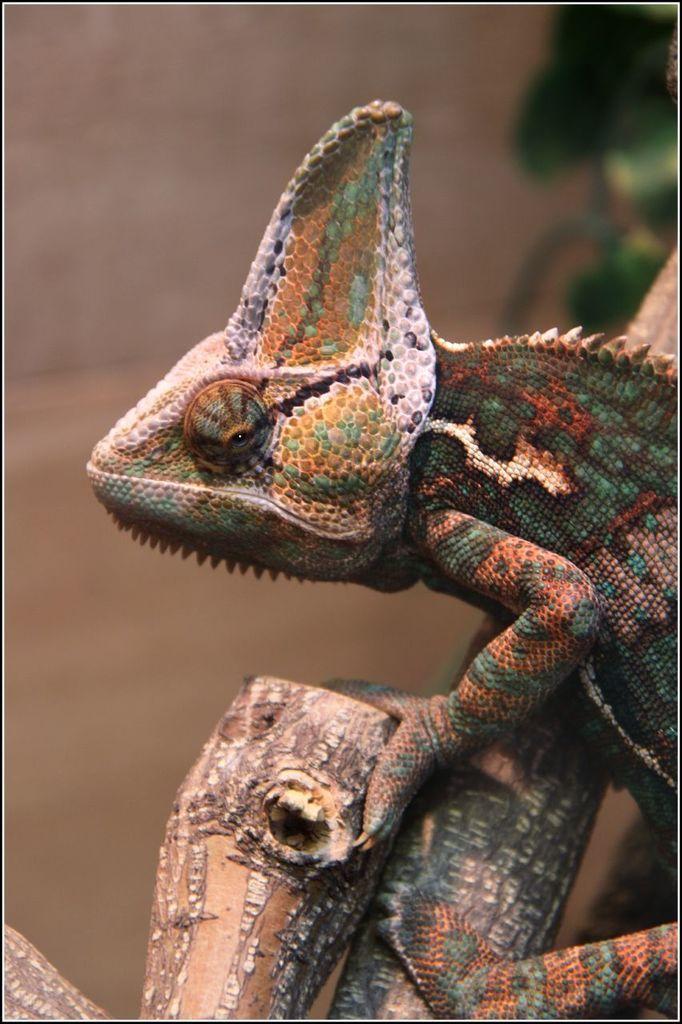In one or two sentences, can you explain what this image depicts? In this picture there is a colorful lizard sitting on the tree branch. Behind there is a blur background. 